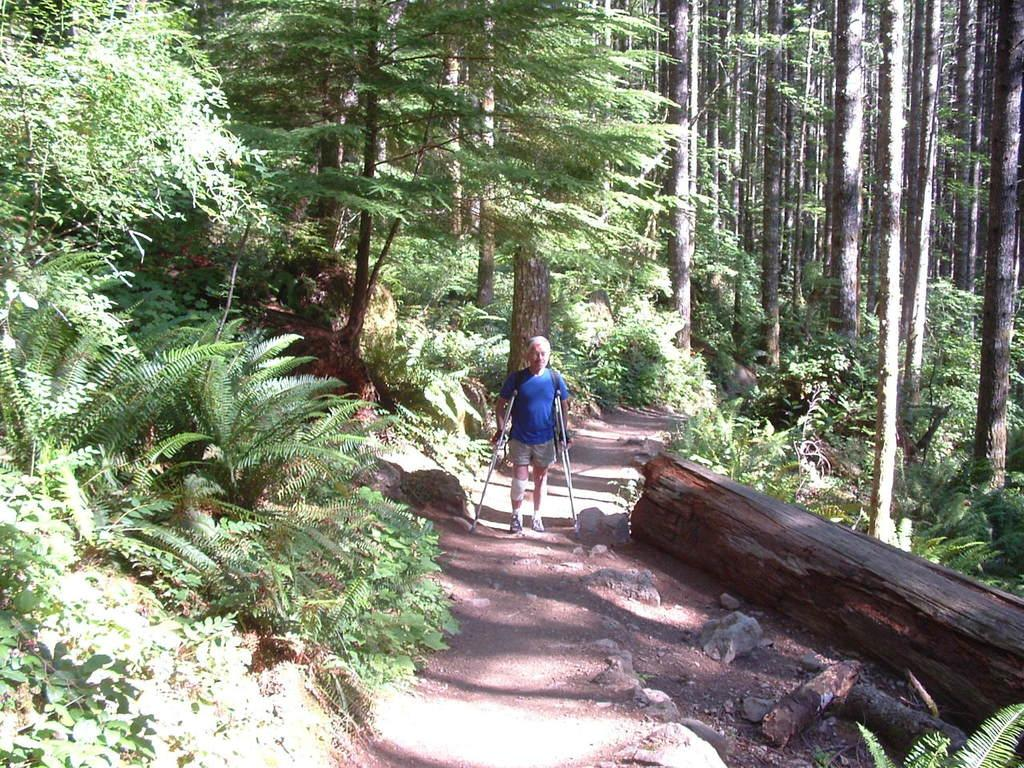What is the main action being performed by the person in the image? The person is walking in the image. What is the person using to assist with walking? The person is using support sticks in the image. What type of natural environment is visible in the image? There are trees and tree trunks visible in the image. What type of cloth is draped over the mine in the image? There is no mine or cloth present in the image; it features a person walking with support sticks in a natural environment with trees and tree trunks. 